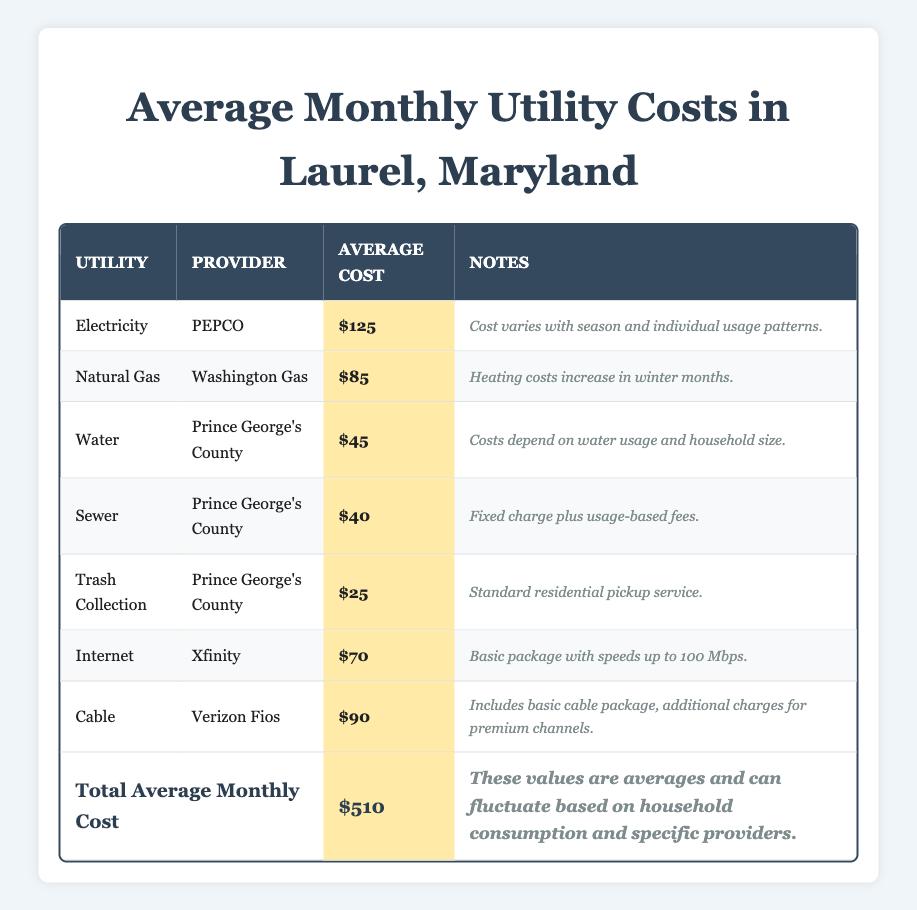What is the average monthly cost for electricity in Laurel, Maryland? The table states that the average cost for electricity provided by PEPCO is $125 per month.
Answer: $125 What is the total average monthly cost for all utilities listed in the table? The table shows a total average monthly cost of $510 for all utilities combined.
Answer: $510 Which utility has the lowest average monthly cost? According to the table, trash collection has the lowest average cost at $25 per month.
Answer: $25 Is the average cost of natural gas higher than that of water? The average cost for natural gas is $85, and for water, it is $45. Since $85 is greater than $45, the statement is true.
Answer: Yes What is the combined average monthly cost of water and sewer services? The average costs for water ($45) and sewer ($40) can be added together: 45 + 40 = 85.
Answer: $85 What percentage of the total average monthly cost does internet service represent? The average cost of internet is $70. To find the percentage, divide $70 by the total cost $510 and multiply by 100: (70 / 510) * 100 ≈ 13.73%.
Answer: Approximately 13.73% If a household wanted to reduce its total utility cost by 10%, what would the target amount be? The total average monthly cost is $510. To find 10%, multiply 510 by 0.10 to get $51. Therefore, the target amount would be 510 - 51 = 459.
Answer: $459 How much more does the average monthly cost of cable exceed the average monthly cost of internet? Cable costs $90 and internet costs $70. The difference can be calculated as 90 - 70 = 20.
Answer: $20 Is the average monthly cost for electricity more than the combined average costs of trash collection and sewer services? The average cost for electricity is $125, while trash collection is $25 and sewer is $40. Adding those two gives 25 + 40 = 65. Since 125 is greater than 65, the statement is true.
Answer: Yes What would be the average monthly cost if a household decides not to subscribe to cable services? By subtracting the cost of cable ($90) from the total average ($510), the new average would be 510 - 90 = 420. If we now consider only the remaining 6 services, the new average is 420 / 6 ≈ 70.
Answer: Approximately $70 